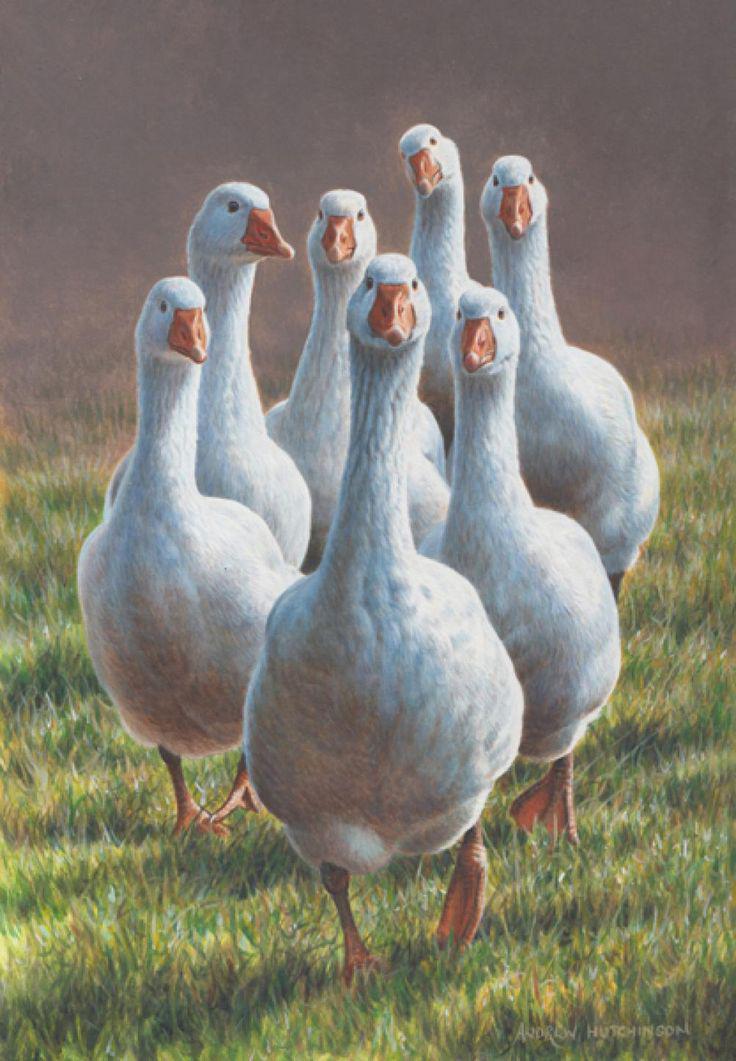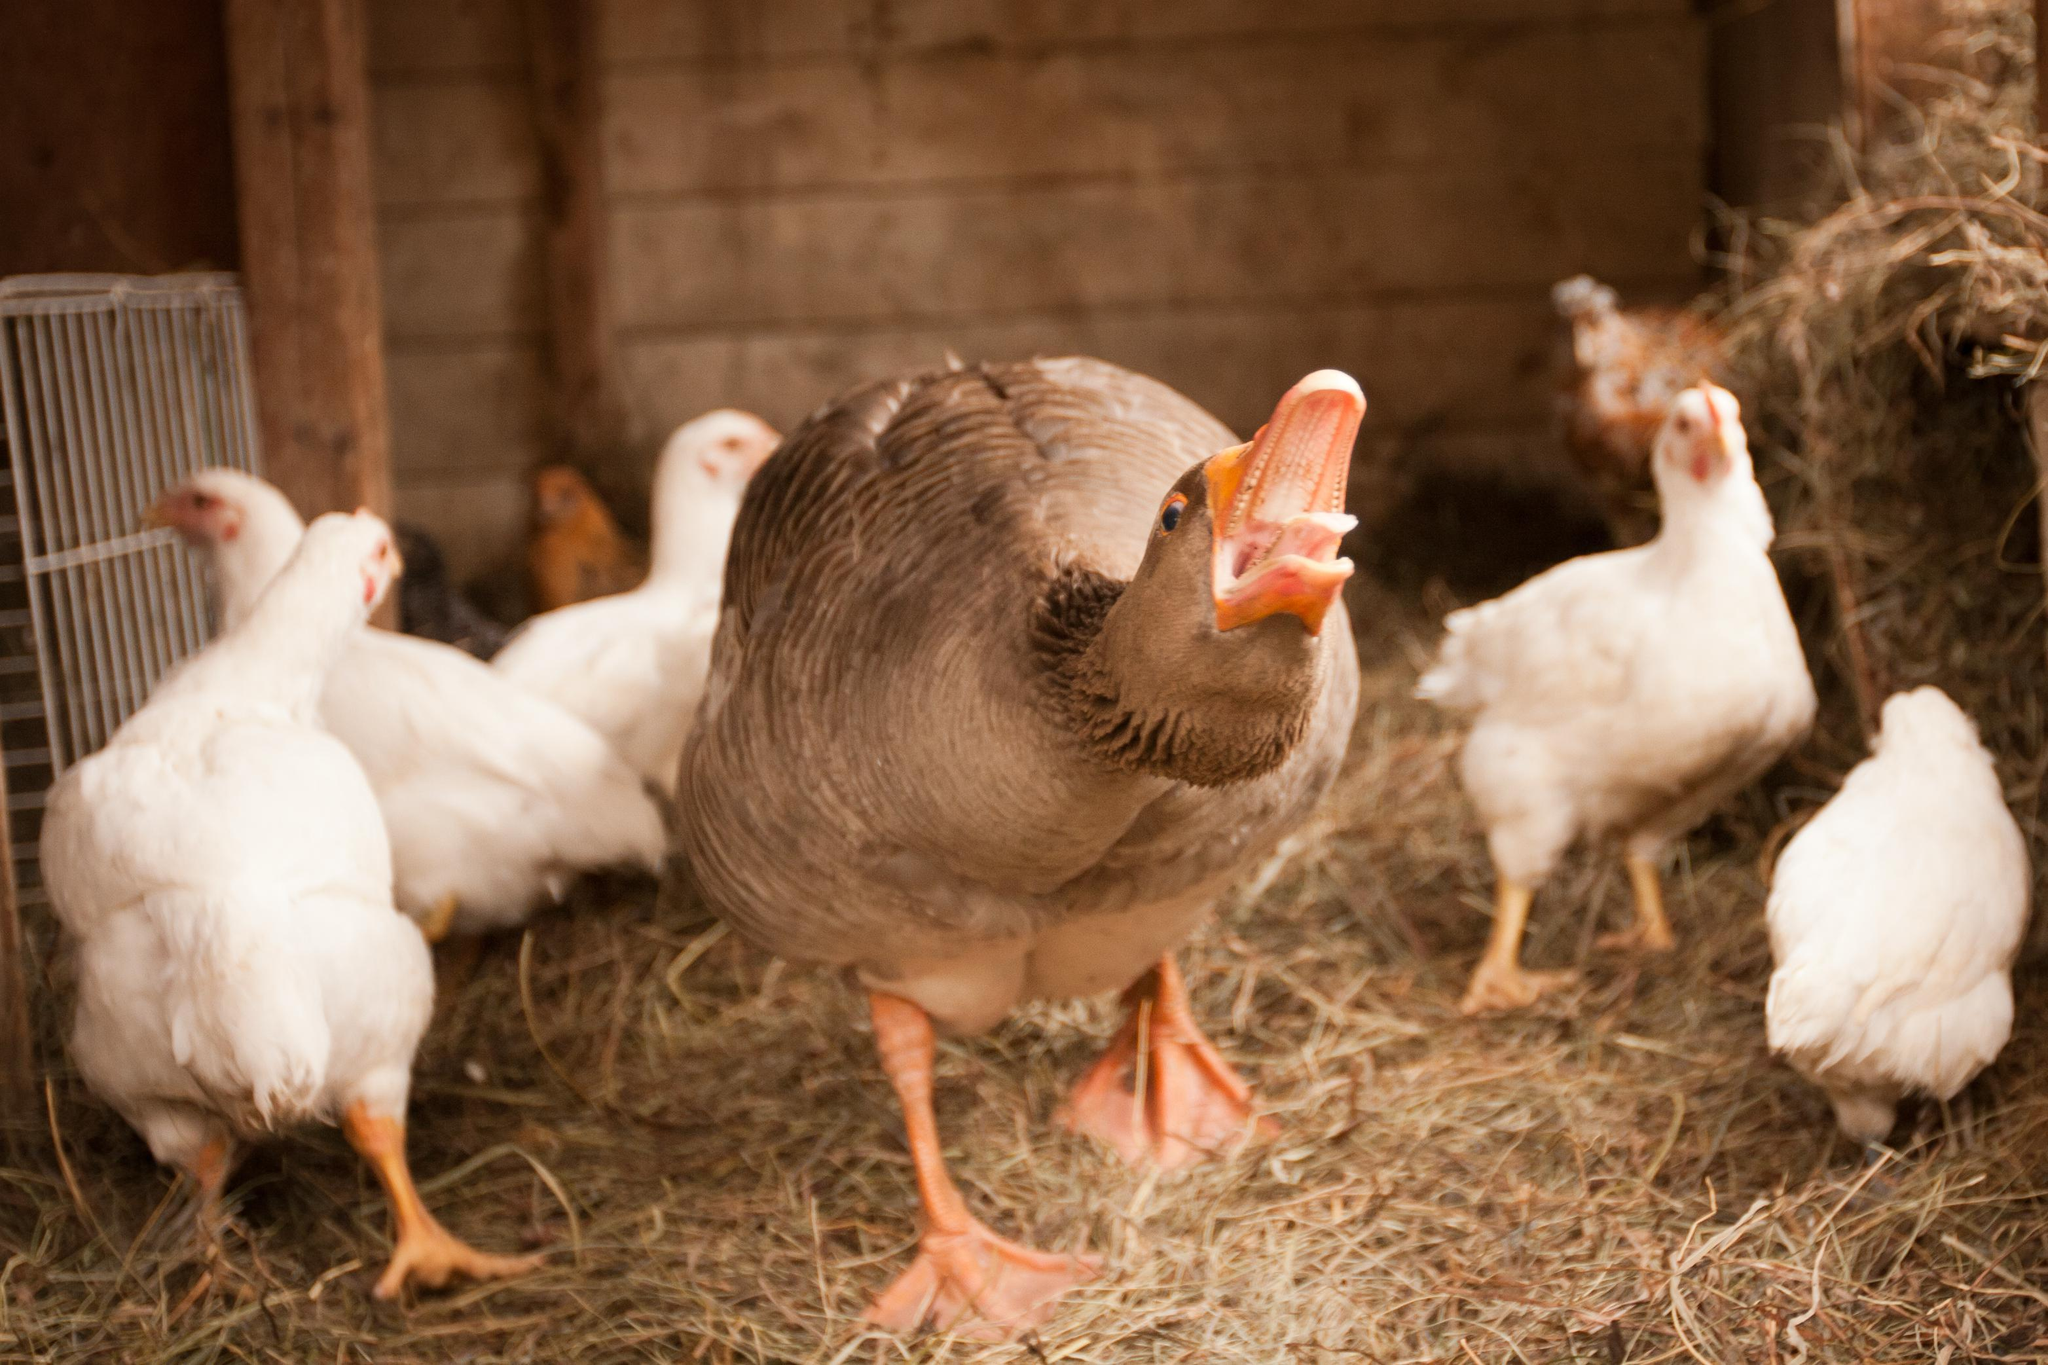The first image is the image on the left, the second image is the image on the right. Considering the images on both sides, is "At least one image shows no less than 20 white fowl." valid? Answer yes or no. No. 